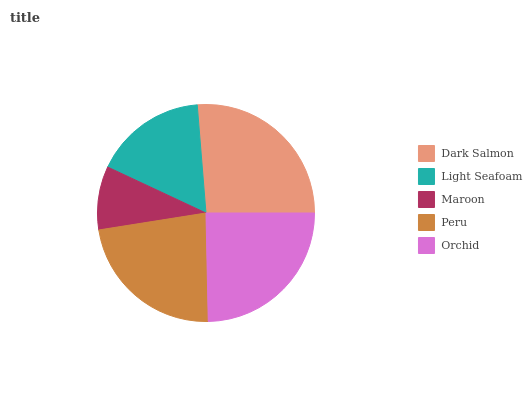Is Maroon the minimum?
Answer yes or no. Yes. Is Dark Salmon the maximum?
Answer yes or no. Yes. Is Light Seafoam the minimum?
Answer yes or no. No. Is Light Seafoam the maximum?
Answer yes or no. No. Is Dark Salmon greater than Light Seafoam?
Answer yes or no. Yes. Is Light Seafoam less than Dark Salmon?
Answer yes or no. Yes. Is Light Seafoam greater than Dark Salmon?
Answer yes or no. No. Is Dark Salmon less than Light Seafoam?
Answer yes or no. No. Is Peru the high median?
Answer yes or no. Yes. Is Peru the low median?
Answer yes or no. Yes. Is Orchid the high median?
Answer yes or no. No. Is Orchid the low median?
Answer yes or no. No. 